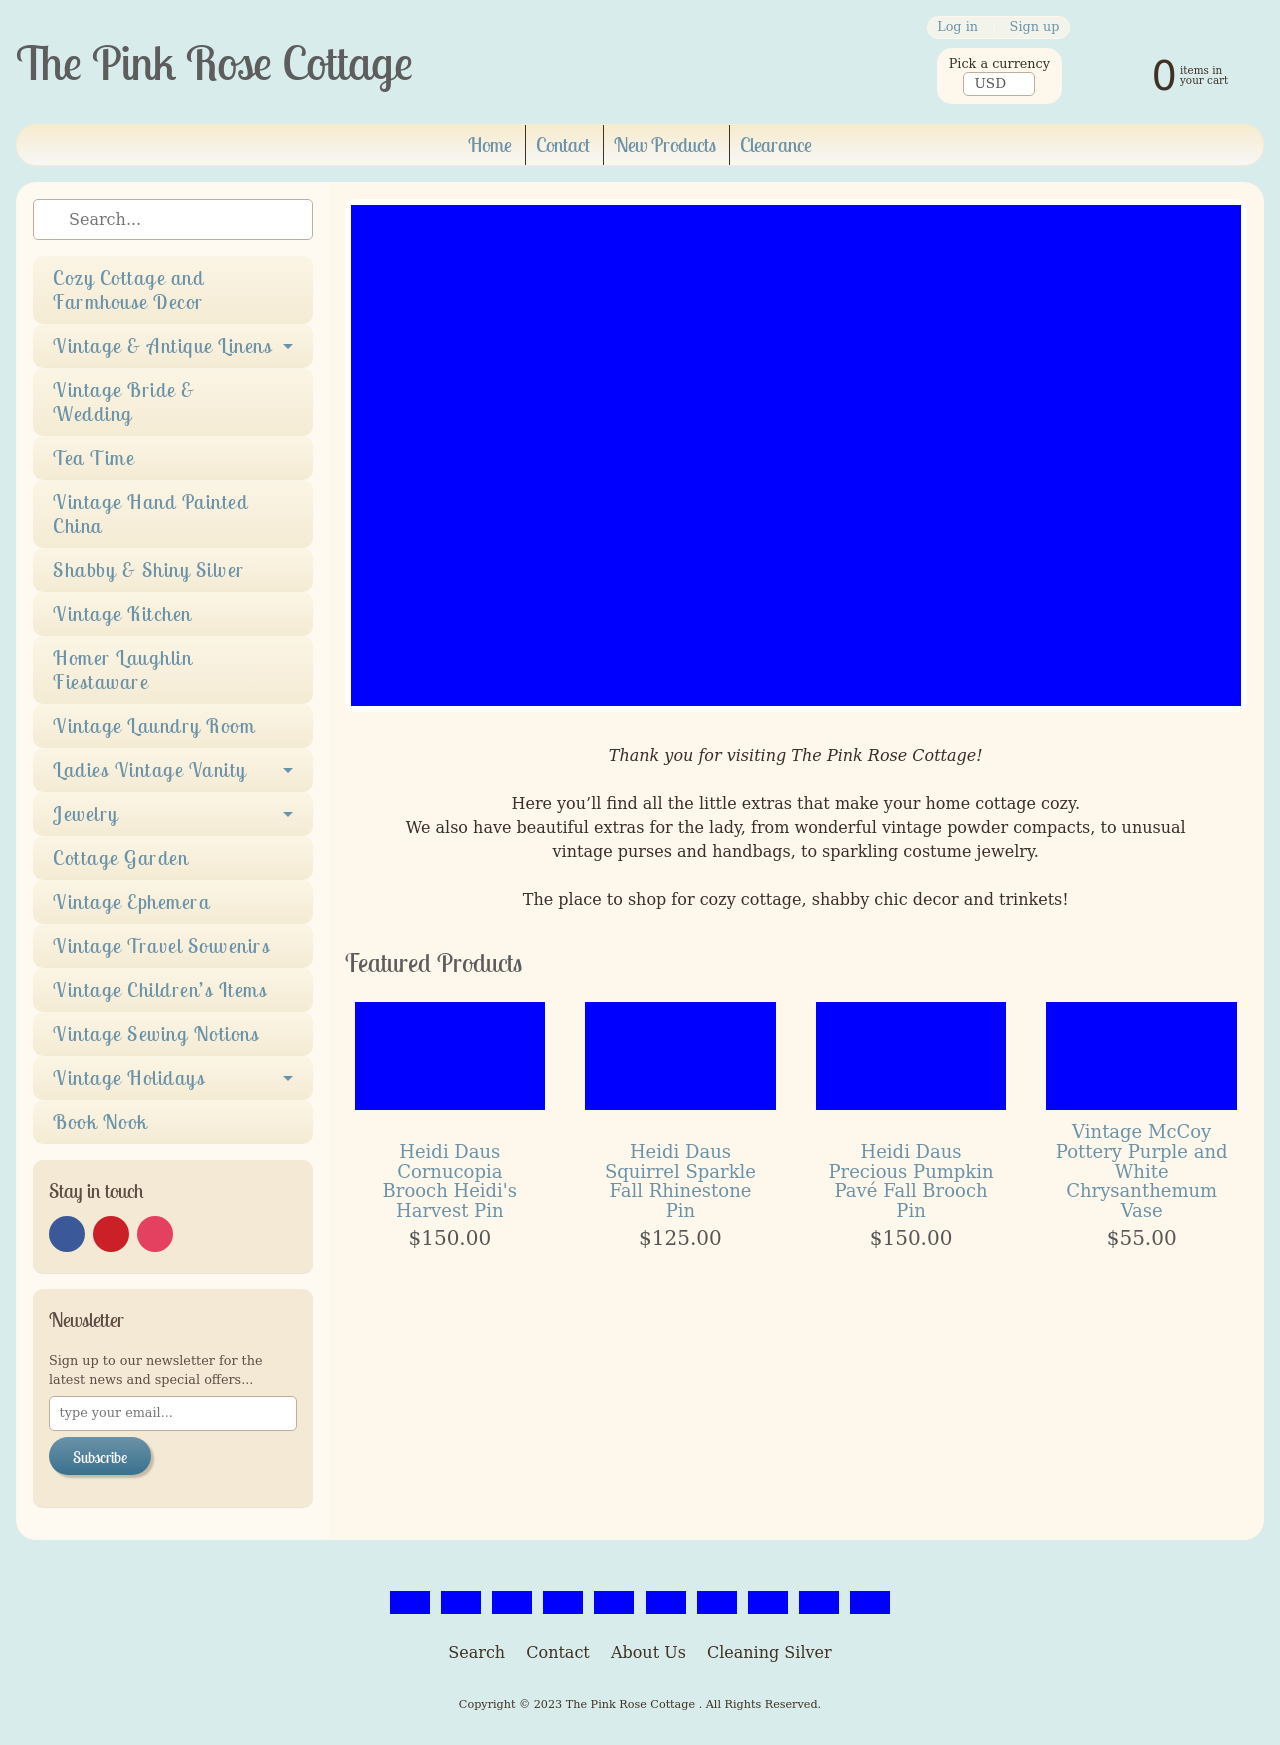Can you tell me more about the 'Vintage Bride & Wedding' section featured in the side menu? The 'Vintage Bride & Wedding' section in The Pink Rose Cottage features an exquisite collection of vintage and antique items perfect for weddings. This includes delicately aged linens, elegant silverware, and unique decorative pieces that add a touch of historical elegance and charm to any wedding setup. Are there any specific items that are popular in this section? Yes, popular items in the 'Vintage Bride & Wedding' section often include vintage lace tablecloths, hand-painted china, and antique brooches which brides commonly use to adorn their dresses or bouquets, adding a vintage flair to their wedding attire. 